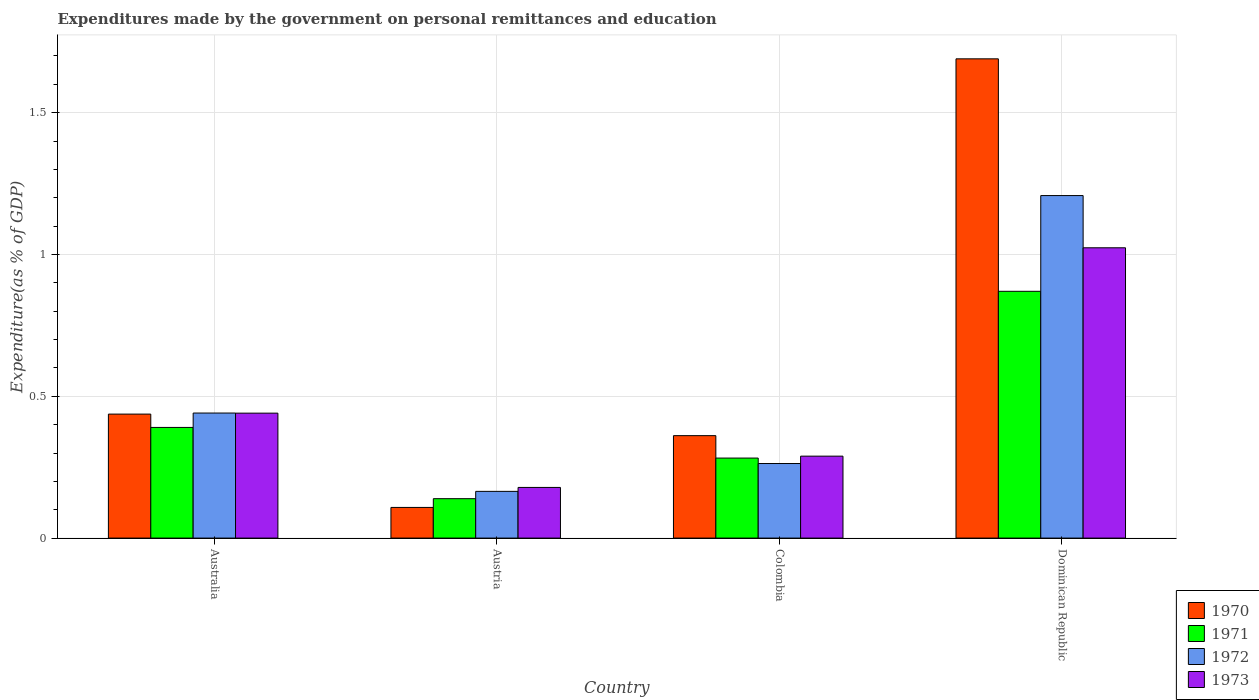How many different coloured bars are there?
Offer a terse response. 4. How many groups of bars are there?
Your answer should be very brief. 4. Are the number of bars on each tick of the X-axis equal?
Your answer should be compact. Yes. How many bars are there on the 3rd tick from the right?
Give a very brief answer. 4. What is the label of the 1st group of bars from the left?
Your answer should be compact. Australia. In how many cases, is the number of bars for a given country not equal to the number of legend labels?
Provide a succinct answer. 0. What is the expenditures made by the government on personal remittances and education in 1970 in Colombia?
Offer a terse response. 0.36. Across all countries, what is the maximum expenditures made by the government on personal remittances and education in 1970?
Your answer should be very brief. 1.69. Across all countries, what is the minimum expenditures made by the government on personal remittances and education in 1970?
Provide a succinct answer. 0.11. In which country was the expenditures made by the government on personal remittances and education in 1970 maximum?
Give a very brief answer. Dominican Republic. In which country was the expenditures made by the government on personal remittances and education in 1972 minimum?
Offer a terse response. Austria. What is the total expenditures made by the government on personal remittances and education in 1972 in the graph?
Keep it short and to the point. 2.08. What is the difference between the expenditures made by the government on personal remittances and education in 1972 in Australia and that in Colombia?
Your response must be concise. 0.18. What is the difference between the expenditures made by the government on personal remittances and education in 1973 in Austria and the expenditures made by the government on personal remittances and education in 1970 in Australia?
Your answer should be very brief. -0.26. What is the average expenditures made by the government on personal remittances and education in 1972 per country?
Your response must be concise. 0.52. What is the difference between the expenditures made by the government on personal remittances and education of/in 1973 and expenditures made by the government on personal remittances and education of/in 1971 in Australia?
Provide a short and direct response. 0.05. What is the ratio of the expenditures made by the government on personal remittances and education in 1973 in Australia to that in Austria?
Your response must be concise. 2.47. Is the expenditures made by the government on personal remittances and education in 1971 in Australia less than that in Austria?
Ensure brevity in your answer.  No. What is the difference between the highest and the second highest expenditures made by the government on personal remittances and education in 1970?
Offer a terse response. -1.25. What is the difference between the highest and the lowest expenditures made by the government on personal remittances and education in 1970?
Offer a very short reply. 1.58. Is the sum of the expenditures made by the government on personal remittances and education in 1970 in Colombia and Dominican Republic greater than the maximum expenditures made by the government on personal remittances and education in 1973 across all countries?
Make the answer very short. Yes. Is it the case that in every country, the sum of the expenditures made by the government on personal remittances and education in 1973 and expenditures made by the government on personal remittances and education in 1972 is greater than the sum of expenditures made by the government on personal remittances and education in 1971 and expenditures made by the government on personal remittances and education in 1970?
Your answer should be compact. No. What does the 1st bar from the left in Austria represents?
Offer a very short reply. 1970. What does the 2nd bar from the right in Austria represents?
Offer a very short reply. 1972. Is it the case that in every country, the sum of the expenditures made by the government on personal remittances and education in 1973 and expenditures made by the government on personal remittances and education in 1970 is greater than the expenditures made by the government on personal remittances and education in 1971?
Make the answer very short. Yes. How many bars are there?
Keep it short and to the point. 16. How many countries are there in the graph?
Make the answer very short. 4. Does the graph contain grids?
Provide a succinct answer. Yes. Where does the legend appear in the graph?
Offer a very short reply. Bottom right. How are the legend labels stacked?
Ensure brevity in your answer.  Vertical. What is the title of the graph?
Keep it short and to the point. Expenditures made by the government on personal remittances and education. Does "1963" appear as one of the legend labels in the graph?
Keep it short and to the point. No. What is the label or title of the Y-axis?
Provide a short and direct response. Expenditure(as % of GDP). What is the Expenditure(as % of GDP) in 1970 in Australia?
Offer a terse response. 0.44. What is the Expenditure(as % of GDP) of 1971 in Australia?
Keep it short and to the point. 0.39. What is the Expenditure(as % of GDP) of 1972 in Australia?
Your answer should be compact. 0.44. What is the Expenditure(as % of GDP) in 1973 in Australia?
Offer a terse response. 0.44. What is the Expenditure(as % of GDP) of 1970 in Austria?
Your response must be concise. 0.11. What is the Expenditure(as % of GDP) in 1971 in Austria?
Ensure brevity in your answer.  0.14. What is the Expenditure(as % of GDP) of 1972 in Austria?
Offer a very short reply. 0.16. What is the Expenditure(as % of GDP) in 1973 in Austria?
Give a very brief answer. 0.18. What is the Expenditure(as % of GDP) of 1970 in Colombia?
Your answer should be compact. 0.36. What is the Expenditure(as % of GDP) in 1971 in Colombia?
Provide a succinct answer. 0.28. What is the Expenditure(as % of GDP) of 1972 in Colombia?
Your response must be concise. 0.26. What is the Expenditure(as % of GDP) of 1973 in Colombia?
Your response must be concise. 0.29. What is the Expenditure(as % of GDP) of 1970 in Dominican Republic?
Your answer should be very brief. 1.69. What is the Expenditure(as % of GDP) in 1971 in Dominican Republic?
Offer a terse response. 0.87. What is the Expenditure(as % of GDP) of 1972 in Dominican Republic?
Provide a short and direct response. 1.21. What is the Expenditure(as % of GDP) in 1973 in Dominican Republic?
Keep it short and to the point. 1.02. Across all countries, what is the maximum Expenditure(as % of GDP) of 1970?
Your response must be concise. 1.69. Across all countries, what is the maximum Expenditure(as % of GDP) in 1971?
Offer a terse response. 0.87. Across all countries, what is the maximum Expenditure(as % of GDP) of 1972?
Keep it short and to the point. 1.21. Across all countries, what is the maximum Expenditure(as % of GDP) in 1973?
Your response must be concise. 1.02. Across all countries, what is the minimum Expenditure(as % of GDP) of 1970?
Your answer should be compact. 0.11. Across all countries, what is the minimum Expenditure(as % of GDP) in 1971?
Ensure brevity in your answer.  0.14. Across all countries, what is the minimum Expenditure(as % of GDP) in 1972?
Make the answer very short. 0.16. Across all countries, what is the minimum Expenditure(as % of GDP) of 1973?
Provide a succinct answer. 0.18. What is the total Expenditure(as % of GDP) in 1970 in the graph?
Your answer should be compact. 2.6. What is the total Expenditure(as % of GDP) in 1971 in the graph?
Your answer should be very brief. 1.68. What is the total Expenditure(as % of GDP) of 1972 in the graph?
Ensure brevity in your answer.  2.08. What is the total Expenditure(as % of GDP) of 1973 in the graph?
Provide a short and direct response. 1.93. What is the difference between the Expenditure(as % of GDP) of 1970 in Australia and that in Austria?
Your response must be concise. 0.33. What is the difference between the Expenditure(as % of GDP) of 1971 in Australia and that in Austria?
Offer a very short reply. 0.25. What is the difference between the Expenditure(as % of GDP) of 1972 in Australia and that in Austria?
Give a very brief answer. 0.28. What is the difference between the Expenditure(as % of GDP) of 1973 in Australia and that in Austria?
Your response must be concise. 0.26. What is the difference between the Expenditure(as % of GDP) of 1970 in Australia and that in Colombia?
Provide a succinct answer. 0.08. What is the difference between the Expenditure(as % of GDP) in 1971 in Australia and that in Colombia?
Offer a very short reply. 0.11. What is the difference between the Expenditure(as % of GDP) of 1972 in Australia and that in Colombia?
Give a very brief answer. 0.18. What is the difference between the Expenditure(as % of GDP) of 1973 in Australia and that in Colombia?
Ensure brevity in your answer.  0.15. What is the difference between the Expenditure(as % of GDP) in 1970 in Australia and that in Dominican Republic?
Make the answer very short. -1.25. What is the difference between the Expenditure(as % of GDP) of 1971 in Australia and that in Dominican Republic?
Give a very brief answer. -0.48. What is the difference between the Expenditure(as % of GDP) of 1972 in Australia and that in Dominican Republic?
Provide a succinct answer. -0.77. What is the difference between the Expenditure(as % of GDP) in 1973 in Australia and that in Dominican Republic?
Provide a succinct answer. -0.58. What is the difference between the Expenditure(as % of GDP) in 1970 in Austria and that in Colombia?
Your response must be concise. -0.25. What is the difference between the Expenditure(as % of GDP) in 1971 in Austria and that in Colombia?
Make the answer very short. -0.14. What is the difference between the Expenditure(as % of GDP) in 1972 in Austria and that in Colombia?
Offer a very short reply. -0.1. What is the difference between the Expenditure(as % of GDP) of 1973 in Austria and that in Colombia?
Offer a very short reply. -0.11. What is the difference between the Expenditure(as % of GDP) in 1970 in Austria and that in Dominican Republic?
Your answer should be compact. -1.58. What is the difference between the Expenditure(as % of GDP) of 1971 in Austria and that in Dominican Republic?
Make the answer very short. -0.73. What is the difference between the Expenditure(as % of GDP) in 1972 in Austria and that in Dominican Republic?
Your response must be concise. -1.04. What is the difference between the Expenditure(as % of GDP) of 1973 in Austria and that in Dominican Republic?
Keep it short and to the point. -0.84. What is the difference between the Expenditure(as % of GDP) of 1970 in Colombia and that in Dominican Republic?
Your answer should be very brief. -1.33. What is the difference between the Expenditure(as % of GDP) of 1971 in Colombia and that in Dominican Republic?
Your answer should be compact. -0.59. What is the difference between the Expenditure(as % of GDP) of 1972 in Colombia and that in Dominican Republic?
Provide a short and direct response. -0.94. What is the difference between the Expenditure(as % of GDP) of 1973 in Colombia and that in Dominican Republic?
Ensure brevity in your answer.  -0.73. What is the difference between the Expenditure(as % of GDP) of 1970 in Australia and the Expenditure(as % of GDP) of 1971 in Austria?
Make the answer very short. 0.3. What is the difference between the Expenditure(as % of GDP) of 1970 in Australia and the Expenditure(as % of GDP) of 1972 in Austria?
Offer a terse response. 0.27. What is the difference between the Expenditure(as % of GDP) in 1970 in Australia and the Expenditure(as % of GDP) in 1973 in Austria?
Offer a very short reply. 0.26. What is the difference between the Expenditure(as % of GDP) in 1971 in Australia and the Expenditure(as % of GDP) in 1972 in Austria?
Give a very brief answer. 0.23. What is the difference between the Expenditure(as % of GDP) in 1971 in Australia and the Expenditure(as % of GDP) in 1973 in Austria?
Offer a terse response. 0.21. What is the difference between the Expenditure(as % of GDP) of 1972 in Australia and the Expenditure(as % of GDP) of 1973 in Austria?
Your answer should be very brief. 0.26. What is the difference between the Expenditure(as % of GDP) of 1970 in Australia and the Expenditure(as % of GDP) of 1971 in Colombia?
Your answer should be compact. 0.15. What is the difference between the Expenditure(as % of GDP) of 1970 in Australia and the Expenditure(as % of GDP) of 1972 in Colombia?
Give a very brief answer. 0.17. What is the difference between the Expenditure(as % of GDP) in 1970 in Australia and the Expenditure(as % of GDP) in 1973 in Colombia?
Your answer should be compact. 0.15. What is the difference between the Expenditure(as % of GDP) of 1971 in Australia and the Expenditure(as % of GDP) of 1972 in Colombia?
Your answer should be very brief. 0.13. What is the difference between the Expenditure(as % of GDP) in 1971 in Australia and the Expenditure(as % of GDP) in 1973 in Colombia?
Offer a terse response. 0.1. What is the difference between the Expenditure(as % of GDP) of 1972 in Australia and the Expenditure(as % of GDP) of 1973 in Colombia?
Offer a very short reply. 0.15. What is the difference between the Expenditure(as % of GDP) of 1970 in Australia and the Expenditure(as % of GDP) of 1971 in Dominican Republic?
Ensure brevity in your answer.  -0.43. What is the difference between the Expenditure(as % of GDP) of 1970 in Australia and the Expenditure(as % of GDP) of 1972 in Dominican Republic?
Ensure brevity in your answer.  -0.77. What is the difference between the Expenditure(as % of GDP) in 1970 in Australia and the Expenditure(as % of GDP) in 1973 in Dominican Republic?
Offer a very short reply. -0.59. What is the difference between the Expenditure(as % of GDP) of 1971 in Australia and the Expenditure(as % of GDP) of 1972 in Dominican Republic?
Make the answer very short. -0.82. What is the difference between the Expenditure(as % of GDP) of 1971 in Australia and the Expenditure(as % of GDP) of 1973 in Dominican Republic?
Provide a short and direct response. -0.63. What is the difference between the Expenditure(as % of GDP) in 1972 in Australia and the Expenditure(as % of GDP) in 1973 in Dominican Republic?
Provide a short and direct response. -0.58. What is the difference between the Expenditure(as % of GDP) of 1970 in Austria and the Expenditure(as % of GDP) of 1971 in Colombia?
Offer a terse response. -0.17. What is the difference between the Expenditure(as % of GDP) of 1970 in Austria and the Expenditure(as % of GDP) of 1972 in Colombia?
Provide a succinct answer. -0.15. What is the difference between the Expenditure(as % of GDP) in 1970 in Austria and the Expenditure(as % of GDP) in 1973 in Colombia?
Ensure brevity in your answer.  -0.18. What is the difference between the Expenditure(as % of GDP) in 1971 in Austria and the Expenditure(as % of GDP) in 1972 in Colombia?
Offer a very short reply. -0.12. What is the difference between the Expenditure(as % of GDP) of 1971 in Austria and the Expenditure(as % of GDP) of 1973 in Colombia?
Your response must be concise. -0.15. What is the difference between the Expenditure(as % of GDP) of 1972 in Austria and the Expenditure(as % of GDP) of 1973 in Colombia?
Your answer should be compact. -0.12. What is the difference between the Expenditure(as % of GDP) of 1970 in Austria and the Expenditure(as % of GDP) of 1971 in Dominican Republic?
Offer a terse response. -0.76. What is the difference between the Expenditure(as % of GDP) in 1970 in Austria and the Expenditure(as % of GDP) in 1972 in Dominican Republic?
Give a very brief answer. -1.1. What is the difference between the Expenditure(as % of GDP) in 1970 in Austria and the Expenditure(as % of GDP) in 1973 in Dominican Republic?
Provide a short and direct response. -0.92. What is the difference between the Expenditure(as % of GDP) in 1971 in Austria and the Expenditure(as % of GDP) in 1972 in Dominican Republic?
Your answer should be compact. -1.07. What is the difference between the Expenditure(as % of GDP) in 1971 in Austria and the Expenditure(as % of GDP) in 1973 in Dominican Republic?
Give a very brief answer. -0.88. What is the difference between the Expenditure(as % of GDP) of 1972 in Austria and the Expenditure(as % of GDP) of 1973 in Dominican Republic?
Provide a succinct answer. -0.86. What is the difference between the Expenditure(as % of GDP) in 1970 in Colombia and the Expenditure(as % of GDP) in 1971 in Dominican Republic?
Ensure brevity in your answer.  -0.51. What is the difference between the Expenditure(as % of GDP) of 1970 in Colombia and the Expenditure(as % of GDP) of 1972 in Dominican Republic?
Your answer should be very brief. -0.85. What is the difference between the Expenditure(as % of GDP) in 1970 in Colombia and the Expenditure(as % of GDP) in 1973 in Dominican Republic?
Give a very brief answer. -0.66. What is the difference between the Expenditure(as % of GDP) in 1971 in Colombia and the Expenditure(as % of GDP) in 1972 in Dominican Republic?
Offer a very short reply. -0.93. What is the difference between the Expenditure(as % of GDP) in 1971 in Colombia and the Expenditure(as % of GDP) in 1973 in Dominican Republic?
Give a very brief answer. -0.74. What is the difference between the Expenditure(as % of GDP) of 1972 in Colombia and the Expenditure(as % of GDP) of 1973 in Dominican Republic?
Your answer should be compact. -0.76. What is the average Expenditure(as % of GDP) in 1970 per country?
Make the answer very short. 0.65. What is the average Expenditure(as % of GDP) of 1971 per country?
Keep it short and to the point. 0.42. What is the average Expenditure(as % of GDP) of 1972 per country?
Ensure brevity in your answer.  0.52. What is the average Expenditure(as % of GDP) of 1973 per country?
Keep it short and to the point. 0.48. What is the difference between the Expenditure(as % of GDP) of 1970 and Expenditure(as % of GDP) of 1971 in Australia?
Your answer should be compact. 0.05. What is the difference between the Expenditure(as % of GDP) of 1970 and Expenditure(as % of GDP) of 1972 in Australia?
Keep it short and to the point. -0. What is the difference between the Expenditure(as % of GDP) of 1970 and Expenditure(as % of GDP) of 1973 in Australia?
Provide a short and direct response. -0. What is the difference between the Expenditure(as % of GDP) of 1971 and Expenditure(as % of GDP) of 1972 in Australia?
Make the answer very short. -0.05. What is the difference between the Expenditure(as % of GDP) of 1971 and Expenditure(as % of GDP) of 1973 in Australia?
Make the answer very short. -0.05. What is the difference between the Expenditure(as % of GDP) in 1970 and Expenditure(as % of GDP) in 1971 in Austria?
Keep it short and to the point. -0.03. What is the difference between the Expenditure(as % of GDP) in 1970 and Expenditure(as % of GDP) in 1972 in Austria?
Ensure brevity in your answer.  -0.06. What is the difference between the Expenditure(as % of GDP) of 1970 and Expenditure(as % of GDP) of 1973 in Austria?
Your answer should be very brief. -0.07. What is the difference between the Expenditure(as % of GDP) of 1971 and Expenditure(as % of GDP) of 1972 in Austria?
Your answer should be very brief. -0.03. What is the difference between the Expenditure(as % of GDP) in 1971 and Expenditure(as % of GDP) in 1973 in Austria?
Provide a short and direct response. -0.04. What is the difference between the Expenditure(as % of GDP) in 1972 and Expenditure(as % of GDP) in 1973 in Austria?
Provide a short and direct response. -0.01. What is the difference between the Expenditure(as % of GDP) in 1970 and Expenditure(as % of GDP) in 1971 in Colombia?
Your answer should be compact. 0.08. What is the difference between the Expenditure(as % of GDP) of 1970 and Expenditure(as % of GDP) of 1972 in Colombia?
Your response must be concise. 0.1. What is the difference between the Expenditure(as % of GDP) in 1970 and Expenditure(as % of GDP) in 1973 in Colombia?
Your answer should be very brief. 0.07. What is the difference between the Expenditure(as % of GDP) in 1971 and Expenditure(as % of GDP) in 1972 in Colombia?
Your answer should be compact. 0.02. What is the difference between the Expenditure(as % of GDP) in 1971 and Expenditure(as % of GDP) in 1973 in Colombia?
Your answer should be compact. -0.01. What is the difference between the Expenditure(as % of GDP) of 1972 and Expenditure(as % of GDP) of 1973 in Colombia?
Keep it short and to the point. -0.03. What is the difference between the Expenditure(as % of GDP) of 1970 and Expenditure(as % of GDP) of 1971 in Dominican Republic?
Your answer should be very brief. 0.82. What is the difference between the Expenditure(as % of GDP) of 1970 and Expenditure(as % of GDP) of 1972 in Dominican Republic?
Your response must be concise. 0.48. What is the difference between the Expenditure(as % of GDP) in 1970 and Expenditure(as % of GDP) in 1973 in Dominican Republic?
Offer a terse response. 0.67. What is the difference between the Expenditure(as % of GDP) of 1971 and Expenditure(as % of GDP) of 1972 in Dominican Republic?
Make the answer very short. -0.34. What is the difference between the Expenditure(as % of GDP) of 1971 and Expenditure(as % of GDP) of 1973 in Dominican Republic?
Your response must be concise. -0.15. What is the difference between the Expenditure(as % of GDP) in 1972 and Expenditure(as % of GDP) in 1973 in Dominican Republic?
Ensure brevity in your answer.  0.18. What is the ratio of the Expenditure(as % of GDP) of 1970 in Australia to that in Austria?
Offer a terse response. 4.04. What is the ratio of the Expenditure(as % of GDP) in 1971 in Australia to that in Austria?
Provide a succinct answer. 2.81. What is the ratio of the Expenditure(as % of GDP) in 1972 in Australia to that in Austria?
Give a very brief answer. 2.68. What is the ratio of the Expenditure(as % of GDP) of 1973 in Australia to that in Austria?
Your answer should be very brief. 2.47. What is the ratio of the Expenditure(as % of GDP) of 1970 in Australia to that in Colombia?
Make the answer very short. 1.21. What is the ratio of the Expenditure(as % of GDP) of 1971 in Australia to that in Colombia?
Give a very brief answer. 1.38. What is the ratio of the Expenditure(as % of GDP) of 1972 in Australia to that in Colombia?
Offer a terse response. 1.68. What is the ratio of the Expenditure(as % of GDP) in 1973 in Australia to that in Colombia?
Your answer should be very brief. 1.52. What is the ratio of the Expenditure(as % of GDP) of 1970 in Australia to that in Dominican Republic?
Give a very brief answer. 0.26. What is the ratio of the Expenditure(as % of GDP) of 1971 in Australia to that in Dominican Republic?
Your response must be concise. 0.45. What is the ratio of the Expenditure(as % of GDP) of 1972 in Australia to that in Dominican Republic?
Your answer should be compact. 0.37. What is the ratio of the Expenditure(as % of GDP) of 1973 in Australia to that in Dominican Republic?
Your response must be concise. 0.43. What is the ratio of the Expenditure(as % of GDP) in 1970 in Austria to that in Colombia?
Your response must be concise. 0.3. What is the ratio of the Expenditure(as % of GDP) in 1971 in Austria to that in Colombia?
Provide a succinct answer. 0.49. What is the ratio of the Expenditure(as % of GDP) of 1972 in Austria to that in Colombia?
Your answer should be compact. 0.63. What is the ratio of the Expenditure(as % of GDP) in 1973 in Austria to that in Colombia?
Your answer should be very brief. 0.62. What is the ratio of the Expenditure(as % of GDP) of 1970 in Austria to that in Dominican Republic?
Offer a terse response. 0.06. What is the ratio of the Expenditure(as % of GDP) in 1971 in Austria to that in Dominican Republic?
Make the answer very short. 0.16. What is the ratio of the Expenditure(as % of GDP) of 1972 in Austria to that in Dominican Republic?
Keep it short and to the point. 0.14. What is the ratio of the Expenditure(as % of GDP) in 1973 in Austria to that in Dominican Republic?
Your answer should be very brief. 0.17. What is the ratio of the Expenditure(as % of GDP) of 1970 in Colombia to that in Dominican Republic?
Provide a succinct answer. 0.21. What is the ratio of the Expenditure(as % of GDP) in 1971 in Colombia to that in Dominican Republic?
Your answer should be compact. 0.32. What is the ratio of the Expenditure(as % of GDP) of 1972 in Colombia to that in Dominican Republic?
Provide a succinct answer. 0.22. What is the ratio of the Expenditure(as % of GDP) in 1973 in Colombia to that in Dominican Republic?
Your answer should be compact. 0.28. What is the difference between the highest and the second highest Expenditure(as % of GDP) in 1970?
Make the answer very short. 1.25. What is the difference between the highest and the second highest Expenditure(as % of GDP) of 1971?
Provide a short and direct response. 0.48. What is the difference between the highest and the second highest Expenditure(as % of GDP) in 1972?
Your answer should be compact. 0.77. What is the difference between the highest and the second highest Expenditure(as % of GDP) in 1973?
Offer a very short reply. 0.58. What is the difference between the highest and the lowest Expenditure(as % of GDP) of 1970?
Make the answer very short. 1.58. What is the difference between the highest and the lowest Expenditure(as % of GDP) of 1971?
Provide a succinct answer. 0.73. What is the difference between the highest and the lowest Expenditure(as % of GDP) in 1972?
Your answer should be very brief. 1.04. What is the difference between the highest and the lowest Expenditure(as % of GDP) of 1973?
Ensure brevity in your answer.  0.84. 